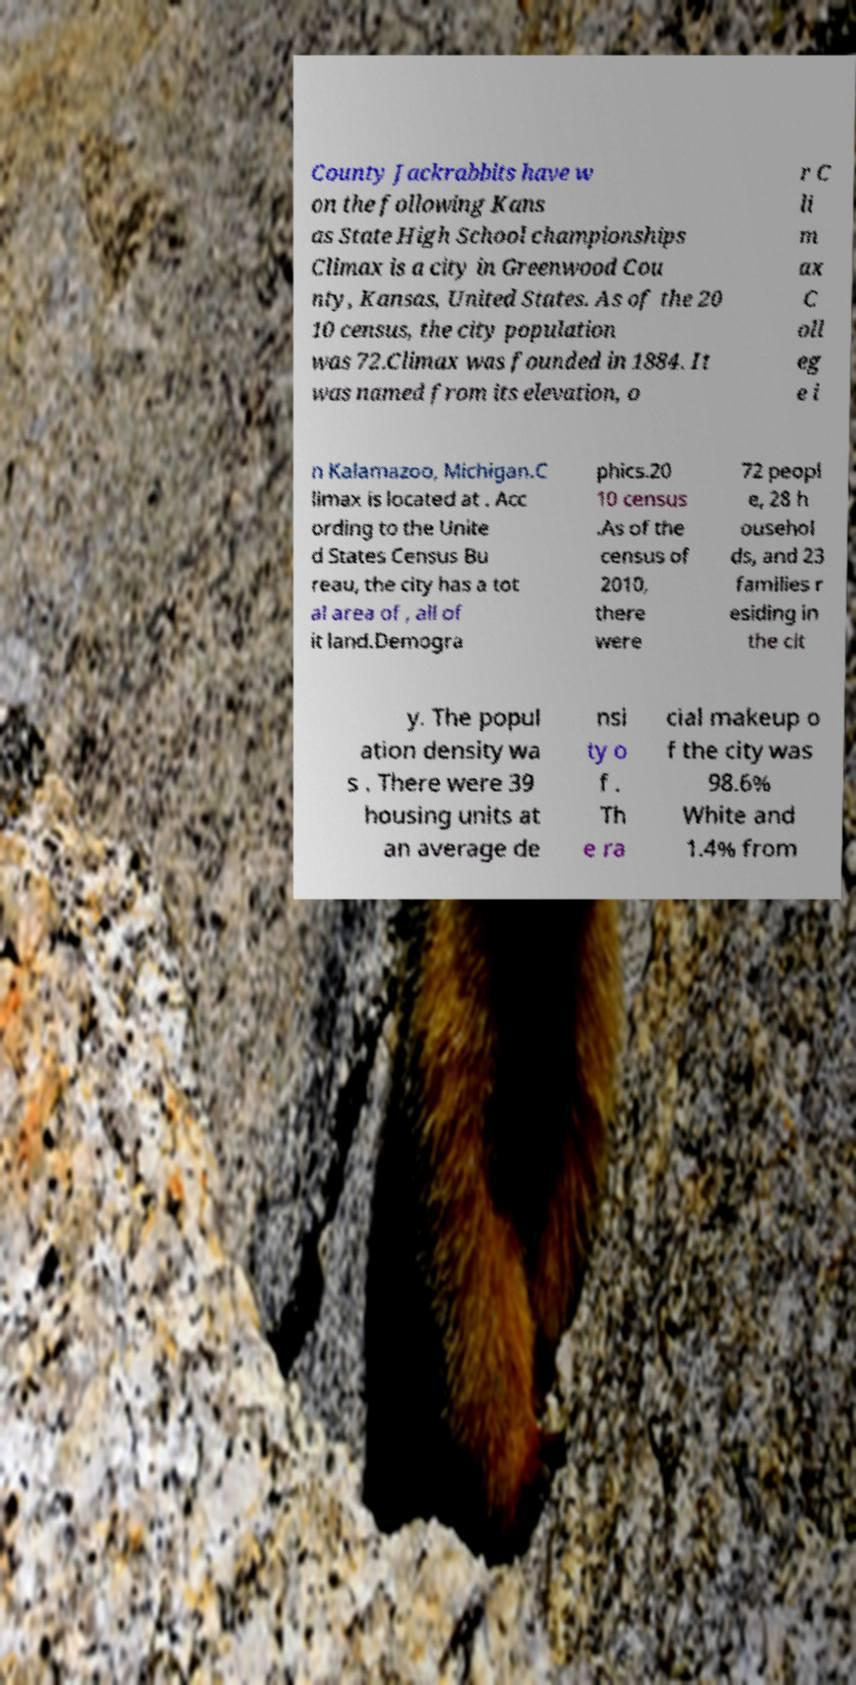Can you accurately transcribe the text from the provided image for me? County Jackrabbits have w on the following Kans as State High School championships Climax is a city in Greenwood Cou nty, Kansas, United States. As of the 20 10 census, the city population was 72.Climax was founded in 1884. It was named from its elevation, o r C li m ax C oll eg e i n Kalamazoo, Michigan.C limax is located at . Acc ording to the Unite d States Census Bu reau, the city has a tot al area of , all of it land.Demogra phics.20 10 census .As of the census of 2010, there were 72 peopl e, 28 h ousehol ds, and 23 families r esiding in the cit y. The popul ation density wa s . There were 39 housing units at an average de nsi ty o f . Th e ra cial makeup o f the city was 98.6% White and 1.4% from 